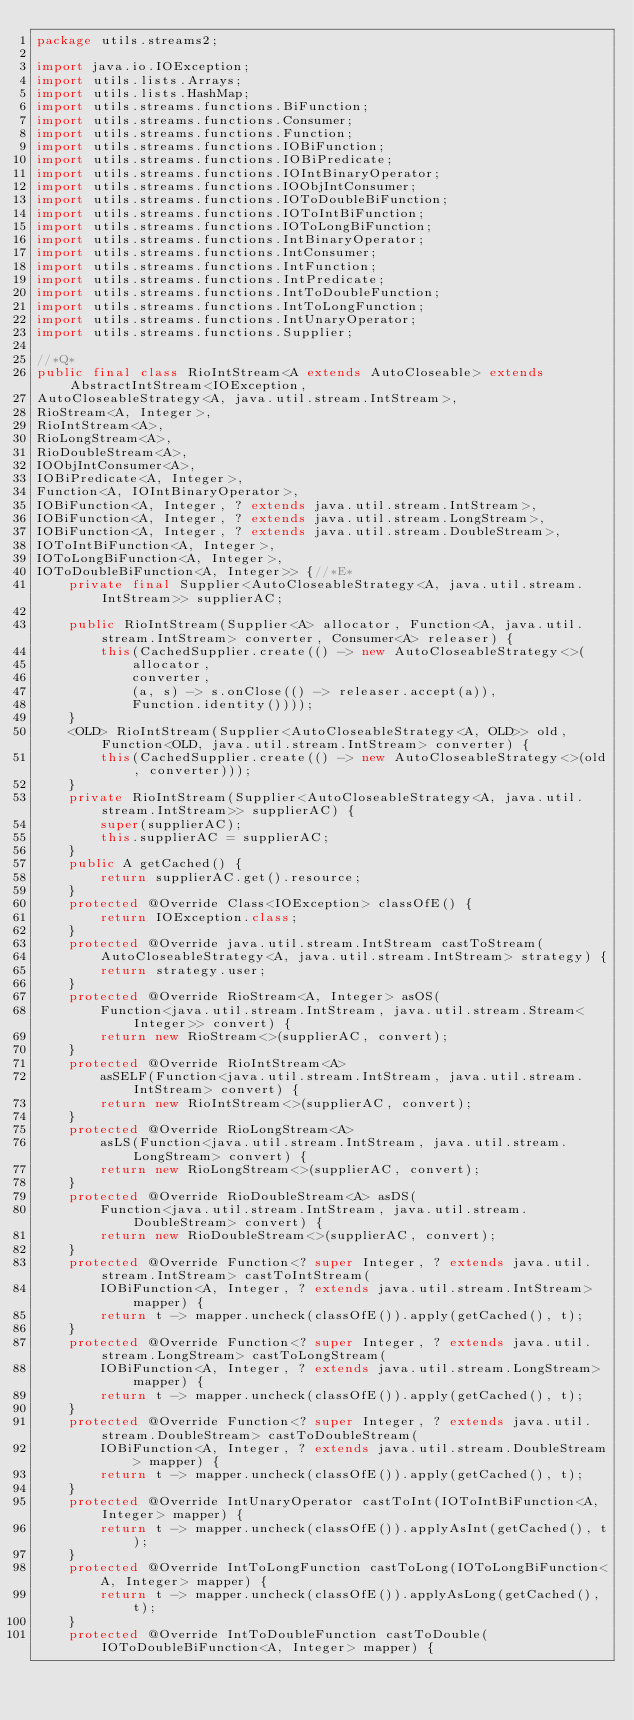Convert code to text. <code><loc_0><loc_0><loc_500><loc_500><_Java_>package utils.streams2;

import java.io.IOException;
import utils.lists.Arrays;
import utils.lists.HashMap;
import utils.streams.functions.BiFunction;
import utils.streams.functions.Consumer;
import utils.streams.functions.Function;
import utils.streams.functions.IOBiFunction;
import utils.streams.functions.IOBiPredicate;
import utils.streams.functions.IOIntBinaryOperator;
import utils.streams.functions.IOObjIntConsumer;
import utils.streams.functions.IOToDoubleBiFunction;
import utils.streams.functions.IOToIntBiFunction;
import utils.streams.functions.IOToLongBiFunction;
import utils.streams.functions.IntBinaryOperator;
import utils.streams.functions.IntConsumer;
import utils.streams.functions.IntFunction;
import utils.streams.functions.IntPredicate;
import utils.streams.functions.IntToDoubleFunction;
import utils.streams.functions.IntToLongFunction;
import utils.streams.functions.IntUnaryOperator;
import utils.streams.functions.Supplier;

//*Q*
public final class RioIntStream<A extends AutoCloseable> extends AbstractIntStream<IOException,
AutoCloseableStrategy<A, java.util.stream.IntStream>,
RioStream<A, Integer>,
RioIntStream<A>,
RioLongStream<A>,
RioDoubleStream<A>,
IOObjIntConsumer<A>,
IOBiPredicate<A, Integer>,
Function<A, IOIntBinaryOperator>,
IOBiFunction<A, Integer, ? extends java.util.stream.IntStream>,
IOBiFunction<A, Integer, ? extends java.util.stream.LongStream>,
IOBiFunction<A, Integer, ? extends java.util.stream.DoubleStream>,
IOToIntBiFunction<A, Integer>,
IOToLongBiFunction<A, Integer>,
IOToDoubleBiFunction<A, Integer>> {//*E*
	private final Supplier<AutoCloseableStrategy<A, java.util.stream.IntStream>> supplierAC;

	public RioIntStream(Supplier<A> allocator, Function<A, java.util.stream.IntStream> converter, Consumer<A> releaser) {
		this(CachedSupplier.create(() -> new AutoCloseableStrategy<>(
			allocator,
			converter,
			(a, s) -> s.onClose(() -> releaser.accept(a)),
			Function.identity())));
	}
	<OLD> RioIntStream(Supplier<AutoCloseableStrategy<A, OLD>> old, Function<OLD, java.util.stream.IntStream> converter) {
		this(CachedSupplier.create(() -> new AutoCloseableStrategy<>(old, converter)));
	}
	private RioIntStream(Supplier<AutoCloseableStrategy<A, java.util.stream.IntStream>> supplierAC) {
		super(supplierAC);
		this.supplierAC = supplierAC;
	}
	public A getCached() {
		return supplierAC.get().resource;
	}
	protected @Override Class<IOException> classOfE() {
		return IOException.class;
	}
	protected @Override java.util.stream.IntStream castToStream(
		AutoCloseableStrategy<A, java.util.stream.IntStream> strategy) {
		return strategy.user;
	}
	protected @Override RioStream<A, Integer> asOS(
		Function<java.util.stream.IntStream, java.util.stream.Stream<Integer>> convert) {
		return new RioStream<>(supplierAC, convert);
	}
	protected @Override RioIntStream<A>
		asSELF(Function<java.util.stream.IntStream, java.util.stream.IntStream> convert) {
		return new RioIntStream<>(supplierAC, convert);
	}
	protected @Override RioLongStream<A>
		asLS(Function<java.util.stream.IntStream, java.util.stream.LongStream> convert) {
		return new RioLongStream<>(supplierAC, convert);
	}
	protected @Override RioDoubleStream<A> asDS(
		Function<java.util.stream.IntStream, java.util.stream.DoubleStream> convert) {
		return new RioDoubleStream<>(supplierAC, convert);
	}
	protected @Override Function<? super Integer, ? extends java.util.stream.IntStream> castToIntStream(
		IOBiFunction<A, Integer, ? extends java.util.stream.IntStream> mapper) {
		return t -> mapper.uncheck(classOfE()).apply(getCached(), t);
	}
	protected @Override Function<? super Integer, ? extends java.util.stream.LongStream> castToLongStream(
		IOBiFunction<A, Integer, ? extends java.util.stream.LongStream> mapper) {
		return t -> mapper.uncheck(classOfE()).apply(getCached(), t);
	}
	protected @Override Function<? super Integer, ? extends java.util.stream.DoubleStream> castToDoubleStream(
		IOBiFunction<A, Integer, ? extends java.util.stream.DoubleStream> mapper) {
		return t -> mapper.uncheck(classOfE()).apply(getCached(), t);
	}
	protected @Override IntUnaryOperator castToInt(IOToIntBiFunction<A, Integer> mapper) {
		return t -> mapper.uncheck(classOfE()).applyAsInt(getCached(), t);
	}
	protected @Override IntToLongFunction castToLong(IOToLongBiFunction<A, Integer> mapper) {
		return t -> mapper.uncheck(classOfE()).applyAsLong(getCached(), t);
	}
	protected @Override IntToDoubleFunction castToDouble(IOToDoubleBiFunction<A, Integer> mapper) {</code> 